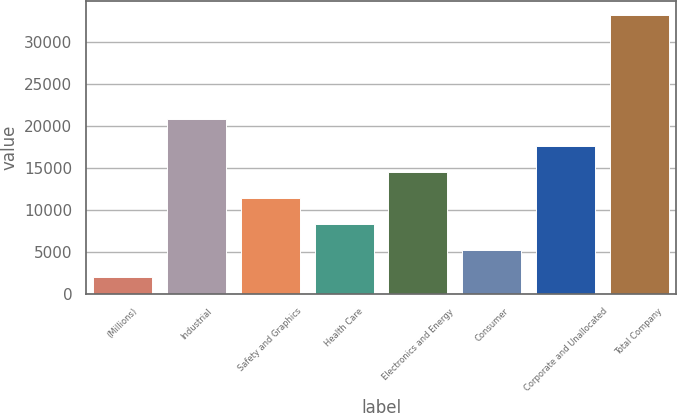Convert chart. <chart><loc_0><loc_0><loc_500><loc_500><bar_chart><fcel>(Millions)<fcel>Industrial<fcel>Safety and Graphics<fcel>Health Care<fcel>Electronics and Energy<fcel>Consumer<fcel>Corporate and Unallocated<fcel>Total Company<nl><fcel>2013<fcel>20787.6<fcel>11400.3<fcel>8271.2<fcel>14529.4<fcel>5142.1<fcel>17658.5<fcel>33304<nl></chart> 